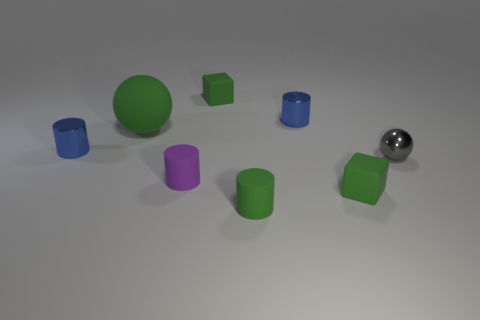Are there any metal things that are left of the tiny green matte block that is to the left of the small matte block in front of the gray thing?
Ensure brevity in your answer.  Yes. The big sphere has what color?
Offer a terse response. Green. There is a ball that is the same size as the green rubber cylinder; what is its color?
Your answer should be very brief. Gray. Does the tiny blue thing that is to the right of the tiny purple thing have the same shape as the small gray object?
Provide a succinct answer. No. There is a tiny block that is to the right of the tiny green block left of the tiny matte block in front of the small purple rubber cylinder; what is its color?
Make the answer very short. Green. Are there any big purple metallic cubes?
Give a very brief answer. No. What number of other things are there of the same size as the purple matte cylinder?
Keep it short and to the point. 6. Does the rubber sphere have the same color as the small rubber block that is behind the small gray sphere?
Offer a terse response. Yes. What number of objects are tiny cubes or large objects?
Your response must be concise. 3. Is there any other thing that has the same color as the metal sphere?
Your answer should be compact. No. 